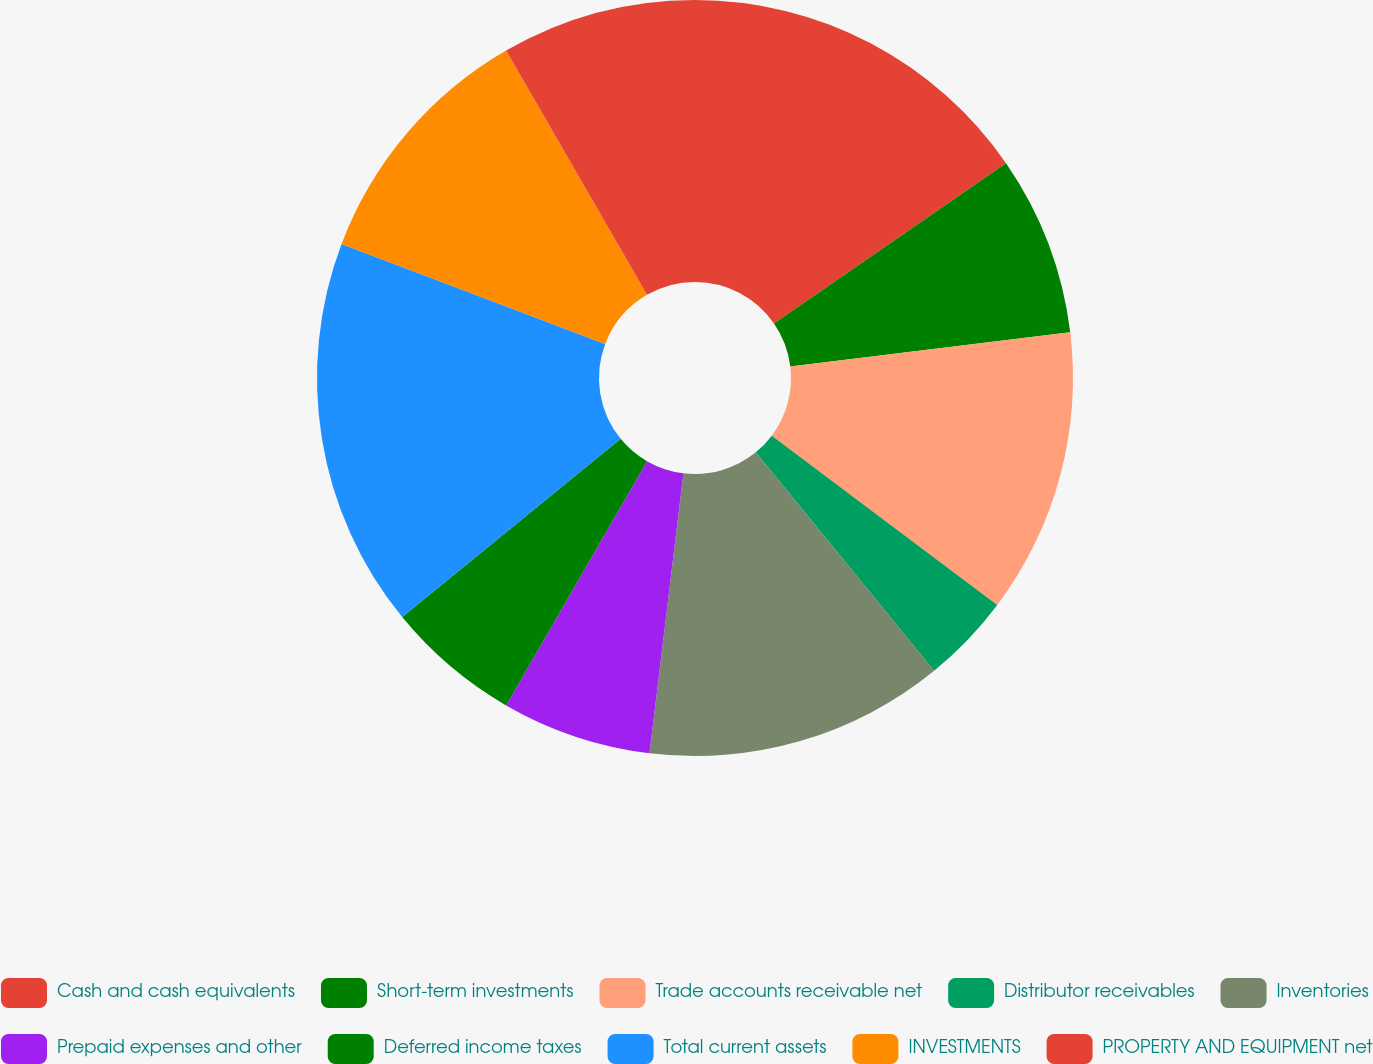Convert chart. <chart><loc_0><loc_0><loc_500><loc_500><pie_chart><fcel>Cash and cash equivalents<fcel>Short-term investments<fcel>Trade accounts receivable net<fcel>Distributor receivables<fcel>Inventories<fcel>Prepaid expenses and other<fcel>Deferred income taxes<fcel>Total current assets<fcel>INVESTMENTS<fcel>PROPERTY AND EQUIPMENT net<nl><fcel>15.38%<fcel>7.69%<fcel>12.18%<fcel>3.85%<fcel>12.82%<fcel>6.41%<fcel>5.77%<fcel>16.67%<fcel>10.9%<fcel>8.33%<nl></chart> 